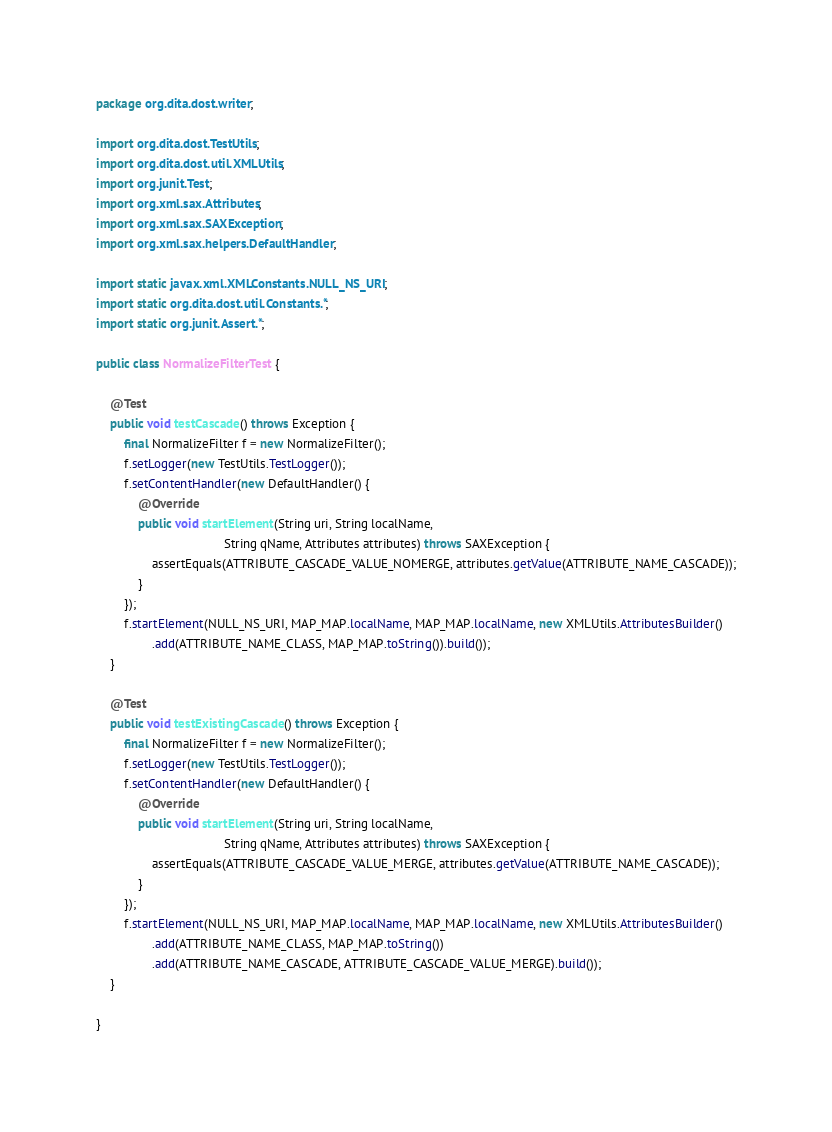<code> <loc_0><loc_0><loc_500><loc_500><_Java_>package org.dita.dost.writer;

import org.dita.dost.TestUtils;
import org.dita.dost.util.XMLUtils;
import org.junit.Test;
import org.xml.sax.Attributes;
import org.xml.sax.SAXException;
import org.xml.sax.helpers.DefaultHandler;

import static javax.xml.XMLConstants.NULL_NS_URI;
import static org.dita.dost.util.Constants.*;
import static org.junit.Assert.*;

public class NormalizeFilterTest {

    @Test
    public void testCascade() throws Exception {
        final NormalizeFilter f = new NormalizeFilter();
        f.setLogger(new TestUtils.TestLogger());
        f.setContentHandler(new DefaultHandler() {
            @Override
            public void startElement(String uri, String localName,
                                     String qName, Attributes attributes) throws SAXException {
                assertEquals(ATTRIBUTE_CASCADE_VALUE_NOMERGE, attributes.getValue(ATTRIBUTE_NAME_CASCADE));
            }
        });
        f.startElement(NULL_NS_URI, MAP_MAP.localName, MAP_MAP.localName, new XMLUtils.AttributesBuilder()
                .add(ATTRIBUTE_NAME_CLASS, MAP_MAP.toString()).build());
    }

    @Test
    public void testExistingCascade() throws Exception {
        final NormalizeFilter f = new NormalizeFilter();
        f.setLogger(new TestUtils.TestLogger());
        f.setContentHandler(new DefaultHandler() {
            @Override
            public void startElement(String uri, String localName,
                                     String qName, Attributes attributes) throws SAXException {
                assertEquals(ATTRIBUTE_CASCADE_VALUE_MERGE, attributes.getValue(ATTRIBUTE_NAME_CASCADE));
            }
        });
        f.startElement(NULL_NS_URI, MAP_MAP.localName, MAP_MAP.localName, new XMLUtils.AttributesBuilder()
                .add(ATTRIBUTE_NAME_CLASS, MAP_MAP.toString())
                .add(ATTRIBUTE_NAME_CASCADE, ATTRIBUTE_CASCADE_VALUE_MERGE).build());
    }

}
</code> 